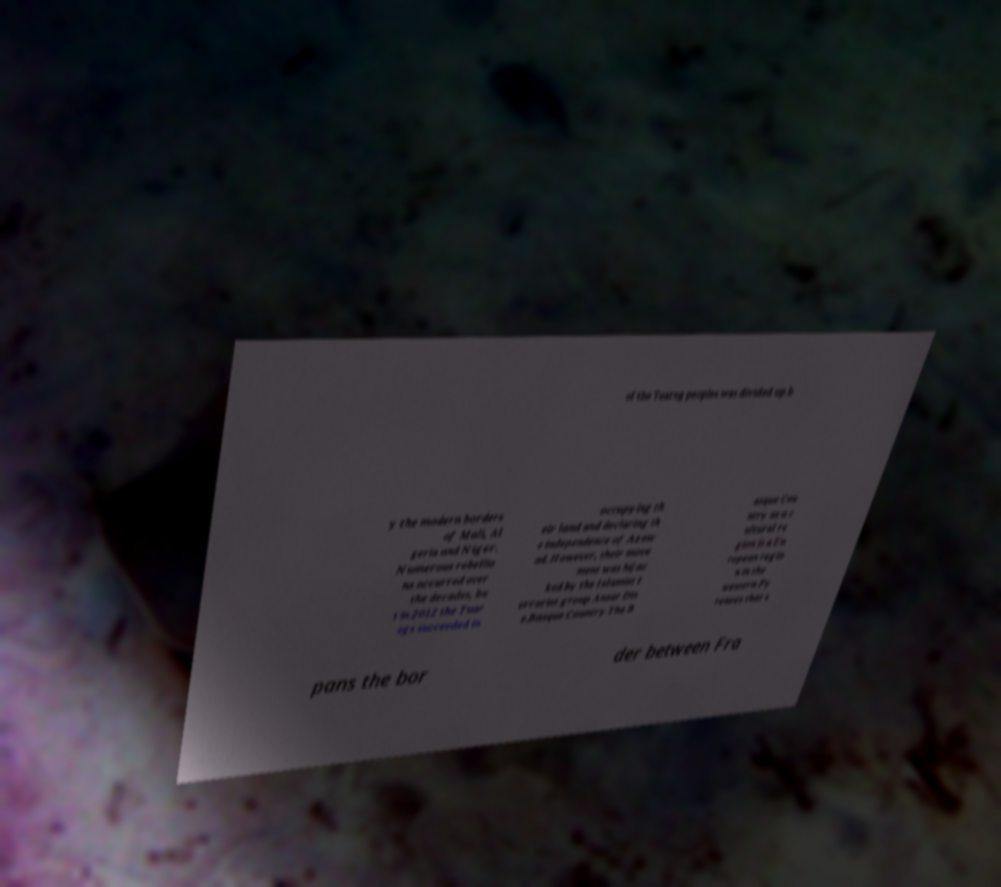What messages or text are displayed in this image? I need them in a readable, typed format. of the Tuareg peoples was divided up b y the modern borders of Mali, Al geria and Niger. Numerous rebellio ns occurred over the decades, bu t in 2012 the Tuar egs succeeded in occupying th eir land and declaring th e independence of Azaw ad. However, their move ment was hijac ked by the Islamist t errorist group Ansar Din e.Basque Country.The B asque Cou ntry as a c ultural re gion is a Eu ropean regio n in the western Py renees that s pans the bor der between Fra 